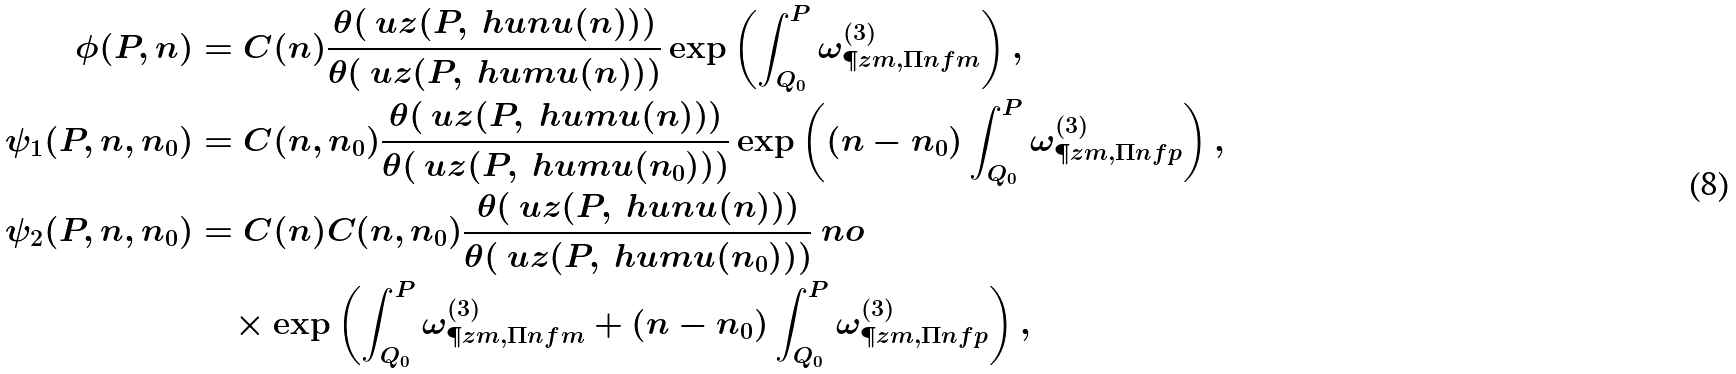<formula> <loc_0><loc_0><loc_500><loc_500>\phi ( P , n ) & = C ( n ) \frac { \theta ( \ u z ( P , \ h u n u ( n ) ) ) } { \theta ( \ u z ( P , \ h u m u ( n ) ) ) } \exp \left ( \int _ { Q _ { 0 } } ^ { P } \omega ^ { ( 3 ) } _ { \P z m , \Pi n f m } \right ) , \\ \psi _ { 1 } ( P , n , n _ { 0 } ) & = C ( n , n _ { 0 } ) \frac { \theta ( \ u z ( P , \ h u m u ( n ) ) ) } { \theta ( \ u z ( P , \ h u m u ( n _ { 0 } ) ) ) } \exp \left ( ( n - n _ { 0 } ) \int _ { Q _ { 0 } } ^ { P } \omega ^ { ( 3 ) } _ { \P z m , \Pi n f p } \right ) , \\ \psi _ { 2 } ( P , n , n _ { 0 } ) & = C ( n ) C ( n , n _ { 0 } ) \frac { \theta ( \ u z ( P , \ h u n u ( n ) ) ) } { \theta ( \ u z ( P , \ h u m u ( n _ { 0 } ) ) ) } \ n o \\ & \quad \times \exp \left ( \int _ { Q _ { 0 } } ^ { P } \omega ^ { ( 3 ) } _ { \P z m , \Pi n f m } + ( n - n _ { 0 } ) \int _ { Q _ { 0 } } ^ { P } \omega ^ { ( 3 ) } _ { \P z m , \Pi n f p } \right ) ,</formula> 